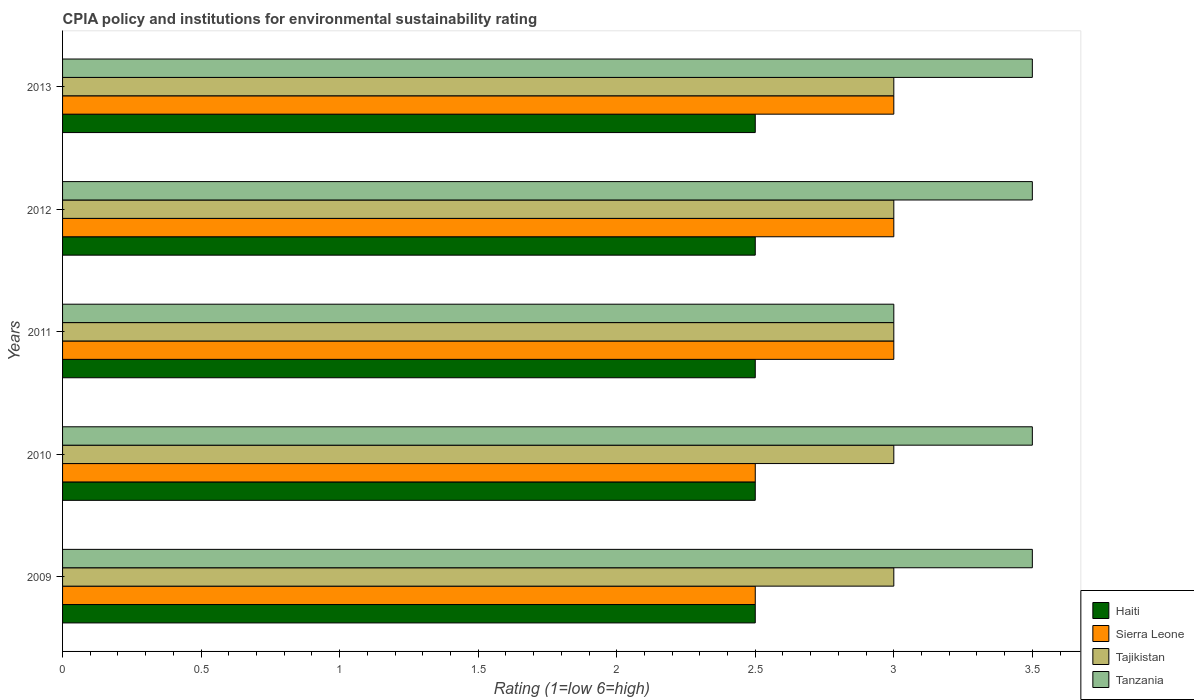Are the number of bars on each tick of the Y-axis equal?
Your response must be concise. Yes. How many bars are there on the 5th tick from the top?
Offer a very short reply. 4. What is the label of the 3rd group of bars from the top?
Provide a succinct answer. 2011. In how many cases, is the number of bars for a given year not equal to the number of legend labels?
Ensure brevity in your answer.  0. What is the difference between the CPIA rating in Sierra Leone in 2010 and that in 2012?
Your response must be concise. -0.5. In the year 2011, what is the difference between the CPIA rating in Haiti and CPIA rating in Sierra Leone?
Make the answer very short. -0.5. What is the ratio of the CPIA rating in Tajikistan in 2010 to that in 2011?
Provide a short and direct response. 1. Is the difference between the CPIA rating in Haiti in 2010 and 2013 greater than the difference between the CPIA rating in Sierra Leone in 2010 and 2013?
Your answer should be very brief. Yes. What is the difference between the highest and the second highest CPIA rating in Tanzania?
Your answer should be very brief. 0. Is it the case that in every year, the sum of the CPIA rating in Tajikistan and CPIA rating in Tanzania is greater than the sum of CPIA rating in Haiti and CPIA rating in Sierra Leone?
Offer a terse response. Yes. What does the 2nd bar from the top in 2011 represents?
Give a very brief answer. Tajikistan. What does the 3rd bar from the bottom in 2011 represents?
Provide a succinct answer. Tajikistan. Does the graph contain any zero values?
Your answer should be very brief. No. Does the graph contain grids?
Your response must be concise. No. Where does the legend appear in the graph?
Make the answer very short. Bottom right. How are the legend labels stacked?
Your answer should be compact. Vertical. What is the title of the graph?
Ensure brevity in your answer.  CPIA policy and institutions for environmental sustainability rating. What is the Rating (1=low 6=high) of Sierra Leone in 2009?
Offer a terse response. 2.5. What is the Rating (1=low 6=high) in Tajikistan in 2009?
Offer a very short reply. 3. What is the Rating (1=low 6=high) in Tanzania in 2009?
Your answer should be very brief. 3.5. What is the Rating (1=low 6=high) in Haiti in 2010?
Your answer should be compact. 2.5. What is the Rating (1=low 6=high) of Sierra Leone in 2010?
Offer a terse response. 2.5. What is the Rating (1=low 6=high) in Tanzania in 2010?
Keep it short and to the point. 3.5. What is the Rating (1=low 6=high) of Haiti in 2011?
Offer a very short reply. 2.5. What is the Rating (1=low 6=high) of Tajikistan in 2011?
Ensure brevity in your answer.  3. What is the Rating (1=low 6=high) of Tanzania in 2011?
Provide a short and direct response. 3. What is the Rating (1=low 6=high) of Haiti in 2012?
Offer a very short reply. 2.5. What is the Rating (1=low 6=high) of Tajikistan in 2012?
Provide a succinct answer. 3. What is the Rating (1=low 6=high) in Haiti in 2013?
Offer a terse response. 2.5. What is the Rating (1=low 6=high) of Sierra Leone in 2013?
Keep it short and to the point. 3. What is the Rating (1=low 6=high) of Tajikistan in 2013?
Give a very brief answer. 3. What is the Rating (1=low 6=high) in Tanzania in 2013?
Provide a succinct answer. 3.5. Across all years, what is the maximum Rating (1=low 6=high) in Haiti?
Your answer should be compact. 2.5. Across all years, what is the maximum Rating (1=low 6=high) of Tajikistan?
Your answer should be compact. 3. Across all years, what is the minimum Rating (1=low 6=high) of Haiti?
Your answer should be compact. 2.5. What is the difference between the Rating (1=low 6=high) in Haiti in 2009 and that in 2010?
Keep it short and to the point. 0. What is the difference between the Rating (1=low 6=high) in Tajikistan in 2009 and that in 2010?
Offer a very short reply. 0. What is the difference between the Rating (1=low 6=high) of Sierra Leone in 2009 and that in 2011?
Provide a short and direct response. -0.5. What is the difference between the Rating (1=low 6=high) in Sierra Leone in 2009 and that in 2012?
Your answer should be very brief. -0.5. What is the difference between the Rating (1=low 6=high) of Tajikistan in 2009 and that in 2012?
Provide a succinct answer. 0. What is the difference between the Rating (1=low 6=high) of Haiti in 2009 and that in 2013?
Your response must be concise. 0. What is the difference between the Rating (1=low 6=high) in Sierra Leone in 2009 and that in 2013?
Your answer should be compact. -0.5. What is the difference between the Rating (1=low 6=high) of Tajikistan in 2009 and that in 2013?
Provide a short and direct response. 0. What is the difference between the Rating (1=low 6=high) of Tanzania in 2009 and that in 2013?
Your response must be concise. 0. What is the difference between the Rating (1=low 6=high) in Haiti in 2010 and that in 2011?
Give a very brief answer. 0. What is the difference between the Rating (1=low 6=high) in Sierra Leone in 2010 and that in 2011?
Give a very brief answer. -0.5. What is the difference between the Rating (1=low 6=high) of Tanzania in 2010 and that in 2011?
Your answer should be very brief. 0.5. What is the difference between the Rating (1=low 6=high) in Tanzania in 2010 and that in 2012?
Provide a short and direct response. 0. What is the difference between the Rating (1=low 6=high) of Tajikistan in 2011 and that in 2012?
Offer a terse response. 0. What is the difference between the Rating (1=low 6=high) of Tanzania in 2011 and that in 2012?
Keep it short and to the point. -0.5. What is the difference between the Rating (1=low 6=high) of Haiti in 2011 and that in 2013?
Give a very brief answer. 0. What is the difference between the Rating (1=low 6=high) in Tajikistan in 2011 and that in 2013?
Give a very brief answer. 0. What is the difference between the Rating (1=low 6=high) of Sierra Leone in 2012 and that in 2013?
Keep it short and to the point. 0. What is the difference between the Rating (1=low 6=high) in Haiti in 2009 and the Rating (1=low 6=high) in Sierra Leone in 2010?
Provide a short and direct response. 0. What is the difference between the Rating (1=low 6=high) in Sierra Leone in 2009 and the Rating (1=low 6=high) in Tajikistan in 2010?
Offer a very short reply. -0.5. What is the difference between the Rating (1=low 6=high) of Tajikistan in 2009 and the Rating (1=low 6=high) of Tanzania in 2010?
Make the answer very short. -0.5. What is the difference between the Rating (1=low 6=high) in Haiti in 2009 and the Rating (1=low 6=high) in Sierra Leone in 2011?
Ensure brevity in your answer.  -0.5. What is the difference between the Rating (1=low 6=high) in Haiti in 2009 and the Rating (1=low 6=high) in Tajikistan in 2011?
Give a very brief answer. -0.5. What is the difference between the Rating (1=low 6=high) in Sierra Leone in 2009 and the Rating (1=low 6=high) in Tanzania in 2011?
Offer a terse response. -0.5. What is the difference between the Rating (1=low 6=high) of Haiti in 2009 and the Rating (1=low 6=high) of Sierra Leone in 2012?
Your answer should be compact. -0.5. What is the difference between the Rating (1=low 6=high) in Haiti in 2009 and the Rating (1=low 6=high) in Tajikistan in 2012?
Keep it short and to the point. -0.5. What is the difference between the Rating (1=low 6=high) in Sierra Leone in 2009 and the Rating (1=low 6=high) in Tajikistan in 2012?
Your answer should be compact. -0.5. What is the difference between the Rating (1=low 6=high) in Sierra Leone in 2009 and the Rating (1=low 6=high) in Tanzania in 2012?
Ensure brevity in your answer.  -1. What is the difference between the Rating (1=low 6=high) of Haiti in 2009 and the Rating (1=low 6=high) of Tajikistan in 2013?
Provide a succinct answer. -0.5. What is the difference between the Rating (1=low 6=high) in Haiti in 2009 and the Rating (1=low 6=high) in Tanzania in 2013?
Offer a very short reply. -1. What is the difference between the Rating (1=low 6=high) of Tajikistan in 2009 and the Rating (1=low 6=high) of Tanzania in 2013?
Your response must be concise. -0.5. What is the difference between the Rating (1=low 6=high) in Haiti in 2010 and the Rating (1=low 6=high) in Tajikistan in 2011?
Keep it short and to the point. -0.5. What is the difference between the Rating (1=low 6=high) of Haiti in 2010 and the Rating (1=low 6=high) of Tanzania in 2011?
Your response must be concise. -0.5. What is the difference between the Rating (1=low 6=high) in Sierra Leone in 2010 and the Rating (1=low 6=high) in Tajikistan in 2011?
Your answer should be compact. -0.5. What is the difference between the Rating (1=low 6=high) of Tajikistan in 2010 and the Rating (1=low 6=high) of Tanzania in 2011?
Offer a terse response. 0. What is the difference between the Rating (1=low 6=high) in Haiti in 2010 and the Rating (1=low 6=high) in Tajikistan in 2012?
Ensure brevity in your answer.  -0.5. What is the difference between the Rating (1=low 6=high) of Sierra Leone in 2010 and the Rating (1=low 6=high) of Tajikistan in 2012?
Your answer should be compact. -0.5. What is the difference between the Rating (1=low 6=high) in Sierra Leone in 2010 and the Rating (1=low 6=high) in Tanzania in 2012?
Ensure brevity in your answer.  -1. What is the difference between the Rating (1=low 6=high) in Haiti in 2010 and the Rating (1=low 6=high) in Sierra Leone in 2013?
Keep it short and to the point. -0.5. What is the difference between the Rating (1=low 6=high) of Sierra Leone in 2010 and the Rating (1=low 6=high) of Tanzania in 2013?
Make the answer very short. -1. What is the difference between the Rating (1=low 6=high) of Tajikistan in 2010 and the Rating (1=low 6=high) of Tanzania in 2013?
Offer a terse response. -0.5. What is the difference between the Rating (1=low 6=high) in Haiti in 2011 and the Rating (1=low 6=high) in Tajikistan in 2012?
Give a very brief answer. -0.5. What is the difference between the Rating (1=low 6=high) of Sierra Leone in 2011 and the Rating (1=low 6=high) of Tajikistan in 2012?
Make the answer very short. 0. What is the difference between the Rating (1=low 6=high) of Sierra Leone in 2011 and the Rating (1=low 6=high) of Tanzania in 2012?
Your answer should be very brief. -0.5. What is the difference between the Rating (1=low 6=high) in Haiti in 2011 and the Rating (1=low 6=high) in Tajikistan in 2013?
Provide a succinct answer. -0.5. What is the difference between the Rating (1=low 6=high) in Haiti in 2011 and the Rating (1=low 6=high) in Tanzania in 2013?
Make the answer very short. -1. What is the difference between the Rating (1=low 6=high) in Sierra Leone in 2011 and the Rating (1=low 6=high) in Tajikistan in 2013?
Your answer should be compact. 0. What is the difference between the Rating (1=low 6=high) of Sierra Leone in 2011 and the Rating (1=low 6=high) of Tanzania in 2013?
Keep it short and to the point. -0.5. What is the difference between the Rating (1=low 6=high) in Haiti in 2012 and the Rating (1=low 6=high) in Sierra Leone in 2013?
Your response must be concise. -0.5. What is the difference between the Rating (1=low 6=high) of Haiti in 2012 and the Rating (1=low 6=high) of Tanzania in 2013?
Your answer should be very brief. -1. What is the difference between the Rating (1=low 6=high) of Sierra Leone in 2012 and the Rating (1=low 6=high) of Tajikistan in 2013?
Provide a succinct answer. 0. What is the average Rating (1=low 6=high) of Haiti per year?
Your response must be concise. 2.5. In the year 2009, what is the difference between the Rating (1=low 6=high) in Haiti and Rating (1=low 6=high) in Sierra Leone?
Make the answer very short. 0. In the year 2009, what is the difference between the Rating (1=low 6=high) in Sierra Leone and Rating (1=low 6=high) in Tajikistan?
Ensure brevity in your answer.  -0.5. In the year 2009, what is the difference between the Rating (1=low 6=high) in Tajikistan and Rating (1=low 6=high) in Tanzania?
Your answer should be very brief. -0.5. In the year 2010, what is the difference between the Rating (1=low 6=high) of Haiti and Rating (1=low 6=high) of Tajikistan?
Offer a very short reply. -0.5. In the year 2010, what is the difference between the Rating (1=low 6=high) in Tajikistan and Rating (1=low 6=high) in Tanzania?
Provide a short and direct response. -0.5. In the year 2011, what is the difference between the Rating (1=low 6=high) of Haiti and Rating (1=low 6=high) of Sierra Leone?
Your answer should be compact. -0.5. In the year 2011, what is the difference between the Rating (1=low 6=high) of Haiti and Rating (1=low 6=high) of Tajikistan?
Your answer should be compact. -0.5. In the year 2011, what is the difference between the Rating (1=low 6=high) of Haiti and Rating (1=low 6=high) of Tanzania?
Give a very brief answer. -0.5. In the year 2011, what is the difference between the Rating (1=low 6=high) in Tajikistan and Rating (1=low 6=high) in Tanzania?
Provide a succinct answer. 0. In the year 2012, what is the difference between the Rating (1=low 6=high) in Haiti and Rating (1=low 6=high) in Sierra Leone?
Ensure brevity in your answer.  -0.5. In the year 2012, what is the difference between the Rating (1=low 6=high) of Sierra Leone and Rating (1=low 6=high) of Tajikistan?
Keep it short and to the point. 0. In the year 2013, what is the difference between the Rating (1=low 6=high) of Haiti and Rating (1=low 6=high) of Tajikistan?
Keep it short and to the point. -0.5. In the year 2013, what is the difference between the Rating (1=low 6=high) of Sierra Leone and Rating (1=low 6=high) of Tajikistan?
Offer a terse response. 0. In the year 2013, what is the difference between the Rating (1=low 6=high) in Tajikistan and Rating (1=low 6=high) in Tanzania?
Offer a terse response. -0.5. What is the ratio of the Rating (1=low 6=high) in Tajikistan in 2009 to that in 2010?
Ensure brevity in your answer.  1. What is the ratio of the Rating (1=low 6=high) in Tanzania in 2009 to that in 2010?
Your response must be concise. 1. What is the ratio of the Rating (1=low 6=high) of Haiti in 2009 to that in 2011?
Make the answer very short. 1. What is the ratio of the Rating (1=low 6=high) of Sierra Leone in 2009 to that in 2011?
Give a very brief answer. 0.83. What is the ratio of the Rating (1=low 6=high) of Tajikistan in 2009 to that in 2011?
Ensure brevity in your answer.  1. What is the ratio of the Rating (1=low 6=high) of Tanzania in 2009 to that in 2011?
Ensure brevity in your answer.  1.17. What is the ratio of the Rating (1=low 6=high) in Tajikistan in 2009 to that in 2012?
Offer a very short reply. 1. What is the ratio of the Rating (1=low 6=high) in Sierra Leone in 2009 to that in 2013?
Keep it short and to the point. 0.83. What is the ratio of the Rating (1=low 6=high) of Haiti in 2010 to that in 2011?
Offer a very short reply. 1. What is the ratio of the Rating (1=low 6=high) in Sierra Leone in 2010 to that in 2011?
Provide a short and direct response. 0.83. What is the ratio of the Rating (1=low 6=high) in Tanzania in 2010 to that in 2011?
Offer a terse response. 1.17. What is the ratio of the Rating (1=low 6=high) of Sierra Leone in 2010 to that in 2012?
Make the answer very short. 0.83. What is the ratio of the Rating (1=low 6=high) in Tajikistan in 2010 to that in 2012?
Offer a very short reply. 1. What is the ratio of the Rating (1=low 6=high) of Tanzania in 2010 to that in 2012?
Provide a succinct answer. 1. What is the ratio of the Rating (1=low 6=high) of Haiti in 2010 to that in 2013?
Your answer should be very brief. 1. What is the ratio of the Rating (1=low 6=high) in Sierra Leone in 2010 to that in 2013?
Keep it short and to the point. 0.83. What is the ratio of the Rating (1=low 6=high) of Tajikistan in 2010 to that in 2013?
Your answer should be very brief. 1. What is the ratio of the Rating (1=low 6=high) in Haiti in 2011 to that in 2012?
Ensure brevity in your answer.  1. What is the ratio of the Rating (1=low 6=high) of Tajikistan in 2011 to that in 2012?
Provide a short and direct response. 1. What is the ratio of the Rating (1=low 6=high) in Tanzania in 2011 to that in 2012?
Provide a short and direct response. 0.86. What is the ratio of the Rating (1=low 6=high) of Haiti in 2011 to that in 2013?
Your answer should be very brief. 1. What is the ratio of the Rating (1=low 6=high) of Sierra Leone in 2011 to that in 2013?
Offer a very short reply. 1. What is the ratio of the Rating (1=low 6=high) of Tajikistan in 2011 to that in 2013?
Ensure brevity in your answer.  1. What is the ratio of the Rating (1=low 6=high) in Tanzania in 2011 to that in 2013?
Keep it short and to the point. 0.86. What is the ratio of the Rating (1=low 6=high) in Haiti in 2012 to that in 2013?
Make the answer very short. 1. What is the ratio of the Rating (1=low 6=high) in Tanzania in 2012 to that in 2013?
Offer a terse response. 1. What is the difference between the highest and the second highest Rating (1=low 6=high) of Haiti?
Offer a terse response. 0. What is the difference between the highest and the second highest Rating (1=low 6=high) in Sierra Leone?
Your answer should be very brief. 0. What is the difference between the highest and the lowest Rating (1=low 6=high) in Tajikistan?
Give a very brief answer. 0. What is the difference between the highest and the lowest Rating (1=low 6=high) of Tanzania?
Your response must be concise. 0.5. 